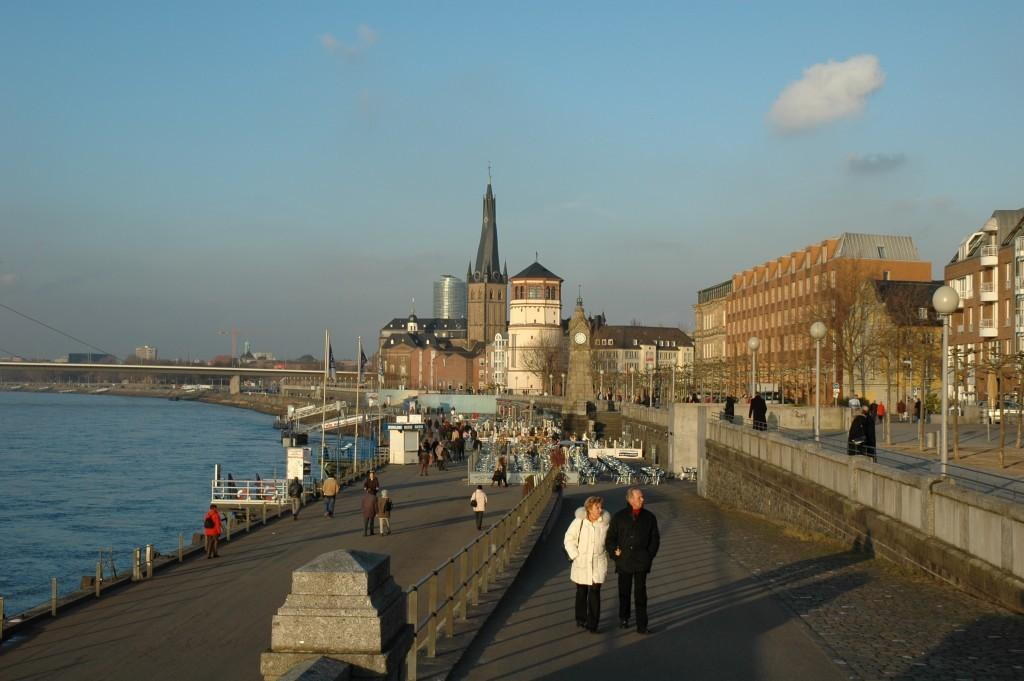Who or what can be seen in the image? There are people in the image. What natural feature is on the left side of the image? There is a sea on the left side of the image. What structures can be seen in the background of the image? There are buildings, trees, and poles in the background of the image. What else is visible in the background of the image? The sky is visible in the background of the image. What feature can be seen in the foreground of the image? There is a railing in the image. What additional objects are present in the image? There are flags in the image. What type of treatment is being administered to the ants in the image? There are no ants present in the image, so no treatment is being administered. 